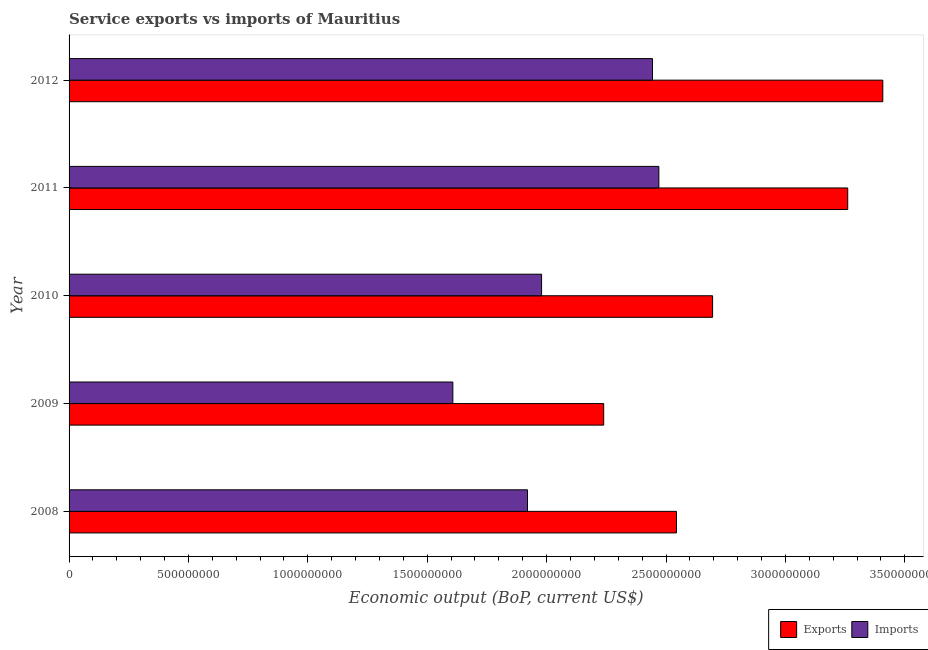Are the number of bars on each tick of the Y-axis equal?
Your answer should be compact. Yes. How many bars are there on the 2nd tick from the top?
Your answer should be compact. 2. How many bars are there on the 4th tick from the bottom?
Offer a very short reply. 2. What is the amount of service exports in 2010?
Provide a short and direct response. 2.70e+09. Across all years, what is the maximum amount of service exports?
Make the answer very short. 3.41e+09. Across all years, what is the minimum amount of service imports?
Provide a short and direct response. 1.61e+09. In which year was the amount of service imports minimum?
Offer a terse response. 2009. What is the total amount of service imports in the graph?
Ensure brevity in your answer.  1.04e+1. What is the difference between the amount of service imports in 2008 and that in 2009?
Provide a short and direct response. 3.13e+08. What is the difference between the amount of service imports in 2008 and the amount of service exports in 2010?
Give a very brief answer. -7.75e+08. What is the average amount of service exports per year?
Your answer should be very brief. 2.83e+09. In the year 2009, what is the difference between the amount of service exports and amount of service imports?
Offer a terse response. 6.32e+08. What is the ratio of the amount of service exports in 2008 to that in 2009?
Provide a short and direct response. 1.14. Is the difference between the amount of service exports in 2008 and 2011 greater than the difference between the amount of service imports in 2008 and 2011?
Ensure brevity in your answer.  No. What is the difference between the highest and the second highest amount of service exports?
Your answer should be very brief. 1.47e+08. What is the difference between the highest and the lowest amount of service imports?
Offer a terse response. 8.63e+08. In how many years, is the amount of service exports greater than the average amount of service exports taken over all years?
Provide a succinct answer. 2. Is the sum of the amount of service imports in 2009 and 2010 greater than the maximum amount of service exports across all years?
Keep it short and to the point. Yes. What does the 1st bar from the top in 2012 represents?
Ensure brevity in your answer.  Imports. What does the 1st bar from the bottom in 2010 represents?
Provide a succinct answer. Exports. How many bars are there?
Keep it short and to the point. 10. Are all the bars in the graph horizontal?
Give a very brief answer. Yes. What is the difference between two consecutive major ticks on the X-axis?
Your answer should be compact. 5.00e+08. Are the values on the major ticks of X-axis written in scientific E-notation?
Your response must be concise. No. Where does the legend appear in the graph?
Make the answer very short. Bottom right. How many legend labels are there?
Give a very brief answer. 2. What is the title of the graph?
Your answer should be compact. Service exports vs imports of Mauritius. Does "Forest land" appear as one of the legend labels in the graph?
Give a very brief answer. No. What is the label or title of the X-axis?
Offer a very short reply. Economic output (BoP, current US$). What is the Economic output (BoP, current US$) of Exports in 2008?
Give a very brief answer. 2.54e+09. What is the Economic output (BoP, current US$) in Imports in 2008?
Your answer should be very brief. 1.92e+09. What is the Economic output (BoP, current US$) of Exports in 2009?
Offer a very short reply. 2.24e+09. What is the Economic output (BoP, current US$) of Imports in 2009?
Keep it short and to the point. 1.61e+09. What is the Economic output (BoP, current US$) of Exports in 2010?
Provide a short and direct response. 2.70e+09. What is the Economic output (BoP, current US$) in Imports in 2010?
Make the answer very short. 1.98e+09. What is the Economic output (BoP, current US$) in Exports in 2011?
Provide a succinct answer. 3.26e+09. What is the Economic output (BoP, current US$) of Imports in 2011?
Your response must be concise. 2.47e+09. What is the Economic output (BoP, current US$) of Exports in 2012?
Provide a short and direct response. 3.41e+09. What is the Economic output (BoP, current US$) of Imports in 2012?
Your answer should be compact. 2.44e+09. Across all years, what is the maximum Economic output (BoP, current US$) in Exports?
Ensure brevity in your answer.  3.41e+09. Across all years, what is the maximum Economic output (BoP, current US$) of Imports?
Keep it short and to the point. 2.47e+09. Across all years, what is the minimum Economic output (BoP, current US$) of Exports?
Provide a succinct answer. 2.24e+09. Across all years, what is the minimum Economic output (BoP, current US$) in Imports?
Provide a succinct answer. 1.61e+09. What is the total Economic output (BoP, current US$) of Exports in the graph?
Offer a very short reply. 1.41e+1. What is the total Economic output (BoP, current US$) of Imports in the graph?
Give a very brief answer. 1.04e+1. What is the difference between the Economic output (BoP, current US$) in Exports in 2008 and that in 2009?
Your answer should be compact. 3.05e+08. What is the difference between the Economic output (BoP, current US$) in Imports in 2008 and that in 2009?
Provide a short and direct response. 3.13e+08. What is the difference between the Economic output (BoP, current US$) of Exports in 2008 and that in 2010?
Give a very brief answer. -1.51e+08. What is the difference between the Economic output (BoP, current US$) of Imports in 2008 and that in 2010?
Ensure brevity in your answer.  -5.90e+07. What is the difference between the Economic output (BoP, current US$) of Exports in 2008 and that in 2011?
Provide a short and direct response. -7.17e+08. What is the difference between the Economic output (BoP, current US$) of Imports in 2008 and that in 2011?
Make the answer very short. -5.50e+08. What is the difference between the Economic output (BoP, current US$) of Exports in 2008 and that in 2012?
Provide a short and direct response. -8.64e+08. What is the difference between the Economic output (BoP, current US$) in Imports in 2008 and that in 2012?
Keep it short and to the point. -5.23e+08. What is the difference between the Economic output (BoP, current US$) in Exports in 2009 and that in 2010?
Your response must be concise. -4.56e+08. What is the difference between the Economic output (BoP, current US$) in Imports in 2009 and that in 2010?
Your answer should be compact. -3.72e+08. What is the difference between the Economic output (BoP, current US$) of Exports in 2009 and that in 2011?
Provide a short and direct response. -1.02e+09. What is the difference between the Economic output (BoP, current US$) of Imports in 2009 and that in 2011?
Keep it short and to the point. -8.63e+08. What is the difference between the Economic output (BoP, current US$) in Exports in 2009 and that in 2012?
Offer a very short reply. -1.17e+09. What is the difference between the Economic output (BoP, current US$) of Imports in 2009 and that in 2012?
Keep it short and to the point. -8.36e+08. What is the difference between the Economic output (BoP, current US$) of Exports in 2010 and that in 2011?
Keep it short and to the point. -5.66e+08. What is the difference between the Economic output (BoP, current US$) in Imports in 2010 and that in 2011?
Your answer should be very brief. -4.91e+08. What is the difference between the Economic output (BoP, current US$) in Exports in 2010 and that in 2012?
Provide a succinct answer. -7.13e+08. What is the difference between the Economic output (BoP, current US$) in Imports in 2010 and that in 2012?
Keep it short and to the point. -4.65e+08. What is the difference between the Economic output (BoP, current US$) in Exports in 2011 and that in 2012?
Offer a terse response. -1.47e+08. What is the difference between the Economic output (BoP, current US$) of Imports in 2011 and that in 2012?
Offer a very short reply. 2.67e+07. What is the difference between the Economic output (BoP, current US$) in Exports in 2008 and the Economic output (BoP, current US$) in Imports in 2009?
Your response must be concise. 9.37e+08. What is the difference between the Economic output (BoP, current US$) in Exports in 2008 and the Economic output (BoP, current US$) in Imports in 2010?
Offer a very short reply. 5.65e+08. What is the difference between the Economic output (BoP, current US$) in Exports in 2008 and the Economic output (BoP, current US$) in Imports in 2011?
Your answer should be compact. 7.38e+07. What is the difference between the Economic output (BoP, current US$) of Exports in 2008 and the Economic output (BoP, current US$) of Imports in 2012?
Ensure brevity in your answer.  1.00e+08. What is the difference between the Economic output (BoP, current US$) of Exports in 2009 and the Economic output (BoP, current US$) of Imports in 2010?
Make the answer very short. 2.60e+08. What is the difference between the Economic output (BoP, current US$) in Exports in 2009 and the Economic output (BoP, current US$) in Imports in 2011?
Offer a terse response. -2.31e+08. What is the difference between the Economic output (BoP, current US$) in Exports in 2009 and the Economic output (BoP, current US$) in Imports in 2012?
Keep it short and to the point. -2.04e+08. What is the difference between the Economic output (BoP, current US$) of Exports in 2010 and the Economic output (BoP, current US$) of Imports in 2011?
Offer a very short reply. 2.25e+08. What is the difference between the Economic output (BoP, current US$) of Exports in 2010 and the Economic output (BoP, current US$) of Imports in 2012?
Provide a succinct answer. 2.52e+08. What is the difference between the Economic output (BoP, current US$) in Exports in 2011 and the Economic output (BoP, current US$) in Imports in 2012?
Give a very brief answer. 8.18e+08. What is the average Economic output (BoP, current US$) of Exports per year?
Provide a short and direct response. 2.83e+09. What is the average Economic output (BoP, current US$) of Imports per year?
Your answer should be compact. 2.08e+09. In the year 2008, what is the difference between the Economic output (BoP, current US$) of Exports and Economic output (BoP, current US$) of Imports?
Your response must be concise. 6.24e+08. In the year 2009, what is the difference between the Economic output (BoP, current US$) of Exports and Economic output (BoP, current US$) of Imports?
Give a very brief answer. 6.32e+08. In the year 2010, what is the difference between the Economic output (BoP, current US$) of Exports and Economic output (BoP, current US$) of Imports?
Keep it short and to the point. 7.16e+08. In the year 2011, what is the difference between the Economic output (BoP, current US$) in Exports and Economic output (BoP, current US$) in Imports?
Your answer should be compact. 7.91e+08. In the year 2012, what is the difference between the Economic output (BoP, current US$) of Exports and Economic output (BoP, current US$) of Imports?
Your answer should be very brief. 9.65e+08. What is the ratio of the Economic output (BoP, current US$) of Exports in 2008 to that in 2009?
Ensure brevity in your answer.  1.14. What is the ratio of the Economic output (BoP, current US$) in Imports in 2008 to that in 2009?
Offer a terse response. 1.19. What is the ratio of the Economic output (BoP, current US$) of Exports in 2008 to that in 2010?
Your answer should be compact. 0.94. What is the ratio of the Economic output (BoP, current US$) in Imports in 2008 to that in 2010?
Make the answer very short. 0.97. What is the ratio of the Economic output (BoP, current US$) in Exports in 2008 to that in 2011?
Provide a succinct answer. 0.78. What is the ratio of the Economic output (BoP, current US$) in Imports in 2008 to that in 2011?
Your response must be concise. 0.78. What is the ratio of the Economic output (BoP, current US$) in Exports in 2008 to that in 2012?
Keep it short and to the point. 0.75. What is the ratio of the Economic output (BoP, current US$) of Imports in 2008 to that in 2012?
Keep it short and to the point. 0.79. What is the ratio of the Economic output (BoP, current US$) of Exports in 2009 to that in 2010?
Your answer should be very brief. 0.83. What is the ratio of the Economic output (BoP, current US$) in Imports in 2009 to that in 2010?
Ensure brevity in your answer.  0.81. What is the ratio of the Economic output (BoP, current US$) in Exports in 2009 to that in 2011?
Your answer should be very brief. 0.69. What is the ratio of the Economic output (BoP, current US$) in Imports in 2009 to that in 2011?
Your answer should be compact. 0.65. What is the ratio of the Economic output (BoP, current US$) in Exports in 2009 to that in 2012?
Your answer should be compact. 0.66. What is the ratio of the Economic output (BoP, current US$) of Imports in 2009 to that in 2012?
Offer a terse response. 0.66. What is the ratio of the Economic output (BoP, current US$) of Exports in 2010 to that in 2011?
Give a very brief answer. 0.83. What is the ratio of the Economic output (BoP, current US$) in Imports in 2010 to that in 2011?
Your answer should be very brief. 0.8. What is the ratio of the Economic output (BoP, current US$) in Exports in 2010 to that in 2012?
Your answer should be very brief. 0.79. What is the ratio of the Economic output (BoP, current US$) in Imports in 2010 to that in 2012?
Provide a succinct answer. 0.81. What is the ratio of the Economic output (BoP, current US$) in Exports in 2011 to that in 2012?
Provide a short and direct response. 0.96. What is the ratio of the Economic output (BoP, current US$) of Imports in 2011 to that in 2012?
Give a very brief answer. 1.01. What is the difference between the highest and the second highest Economic output (BoP, current US$) in Exports?
Offer a very short reply. 1.47e+08. What is the difference between the highest and the second highest Economic output (BoP, current US$) of Imports?
Your answer should be very brief. 2.67e+07. What is the difference between the highest and the lowest Economic output (BoP, current US$) in Exports?
Offer a terse response. 1.17e+09. What is the difference between the highest and the lowest Economic output (BoP, current US$) in Imports?
Your answer should be very brief. 8.63e+08. 